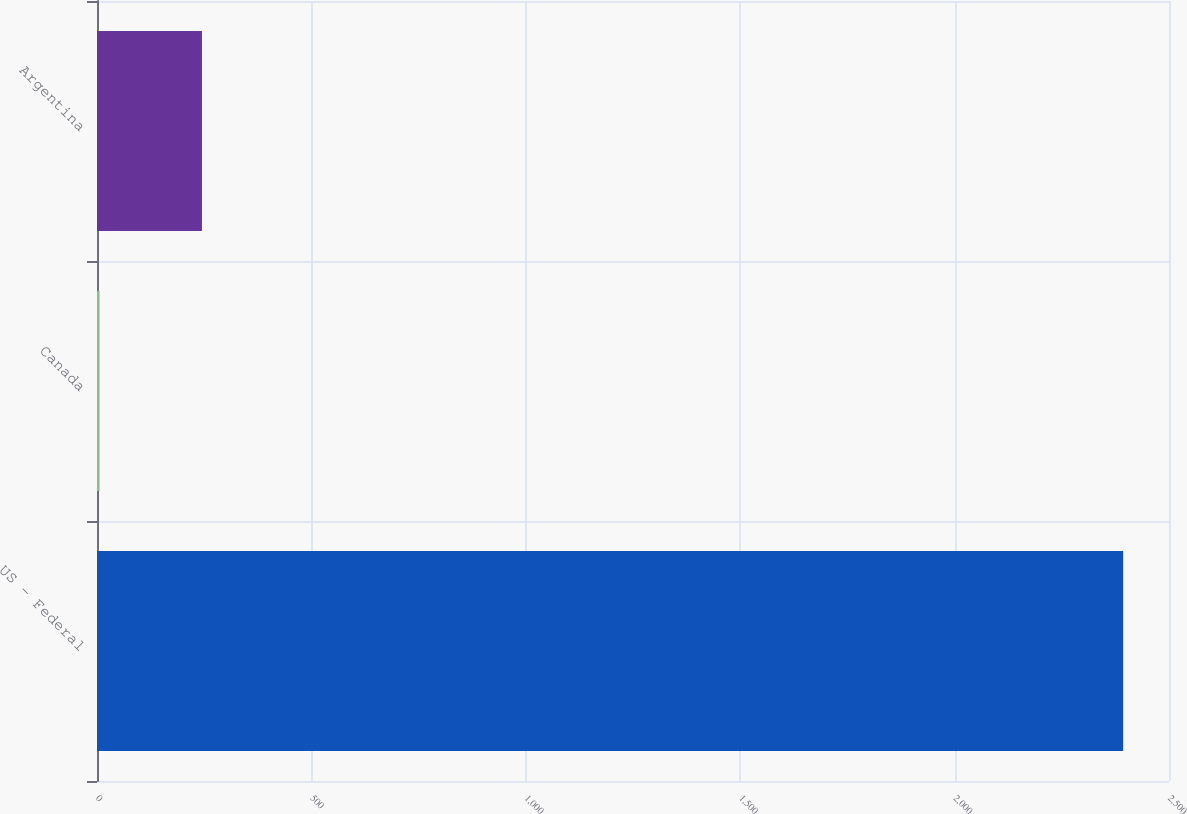Convert chart. <chart><loc_0><loc_0><loc_500><loc_500><bar_chart><fcel>US - Federal<fcel>Canada<fcel>Argentina<nl><fcel>2393<fcel>6<fcel>244.7<nl></chart> 